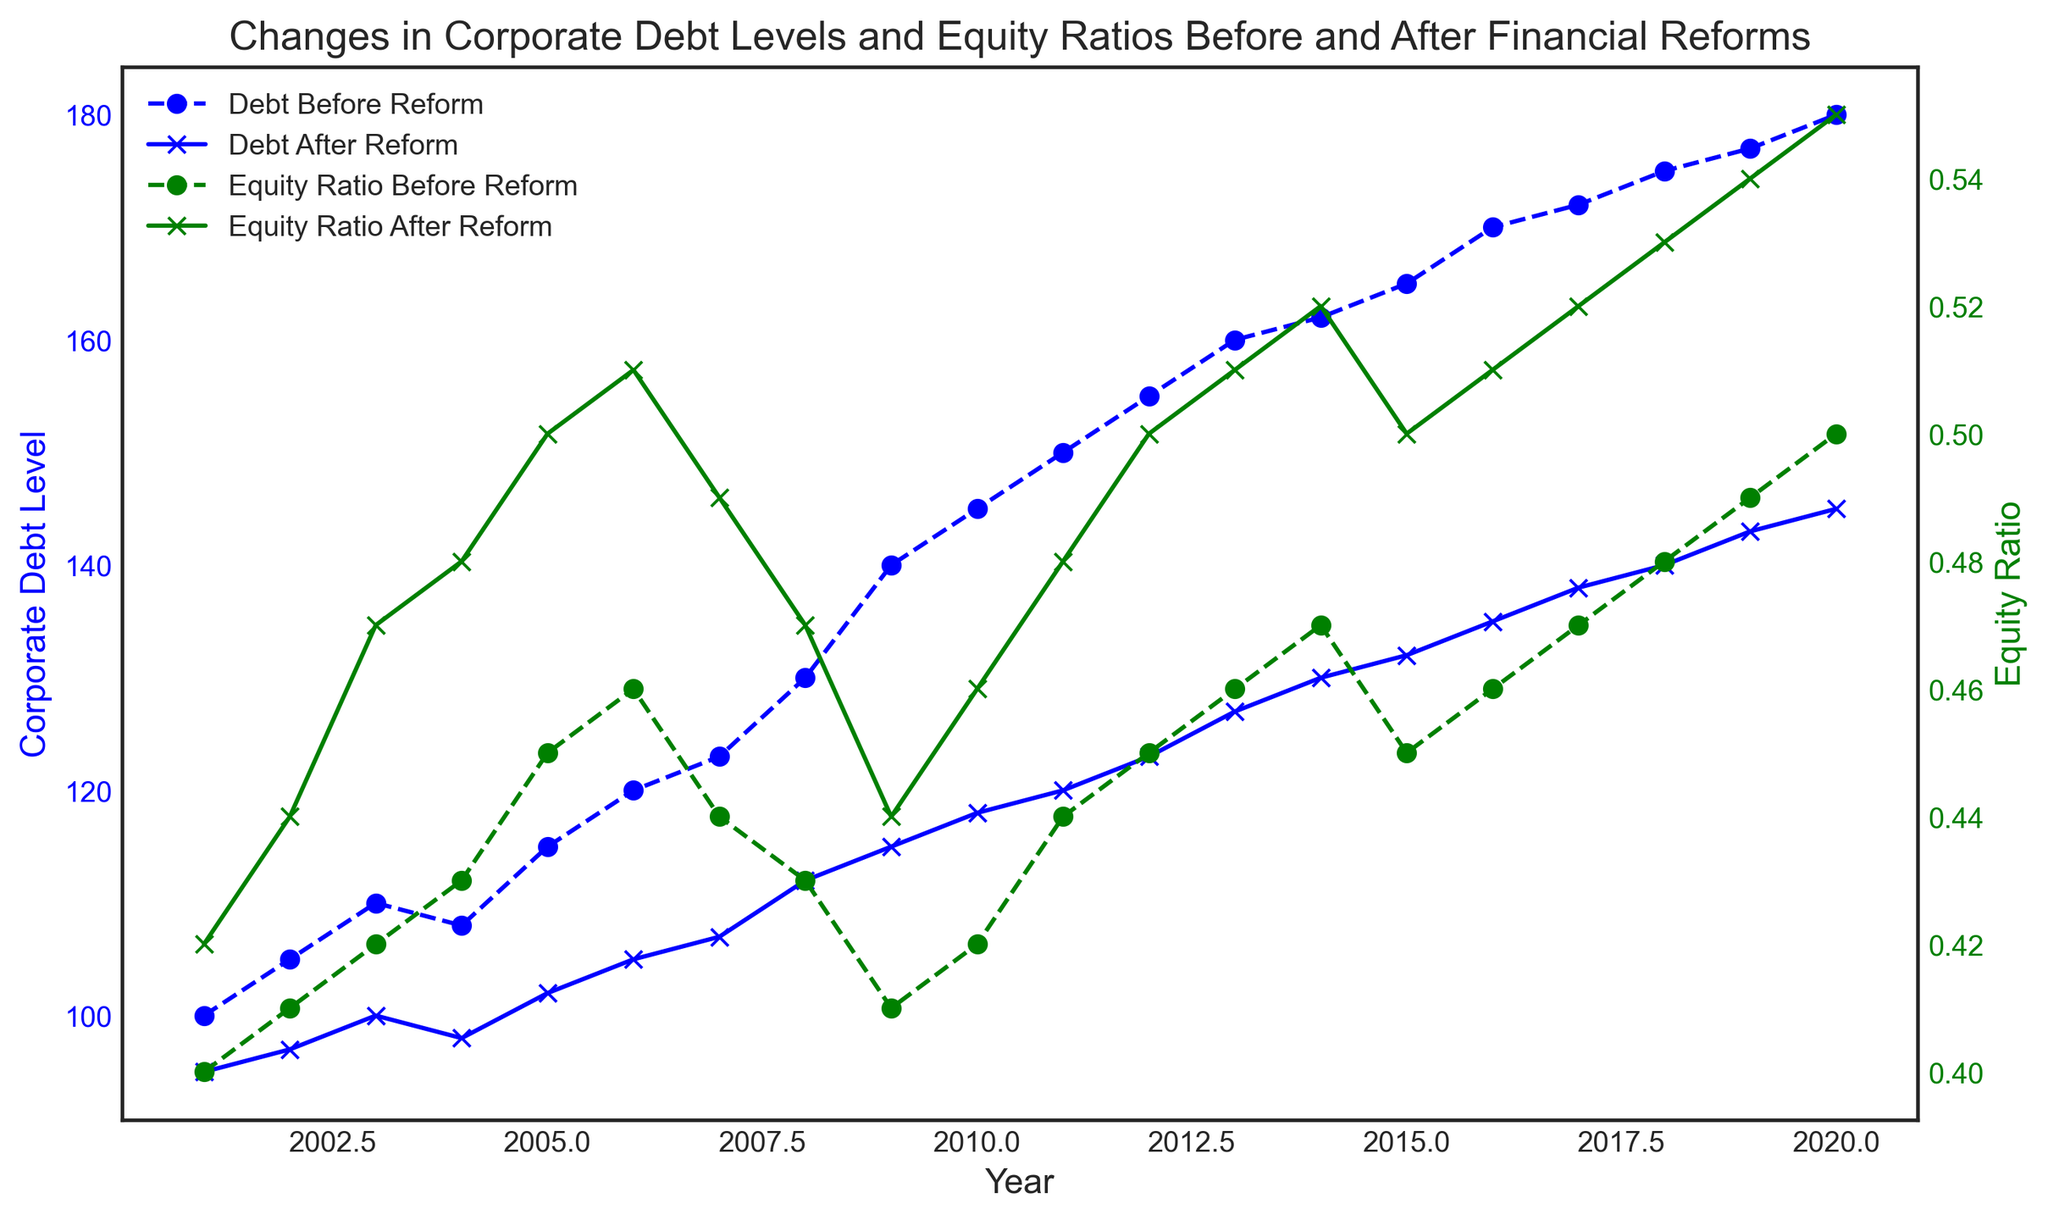What is the overall trend in the Corporate Debt Level before the reform from 2001 to 2020? The Corporate Debt Level before the reform shows a general increasing trend from 100 in 2001 to 180 in 2020, with some fluctuations in between.
Answer: Increasing trend Which year shows the largest difference in corporate debt levels between before and after the reform? The largest difference in corporate debt levels between before and after the reform occurs in 2020, with a difference of 35 (180 before, 145 after).
Answer: 2020 How do the Equity Ratios in 2009 compare before and after the reform? In 2009, the Equity Ratio before the reform is 0.41, and the Equity Ratio after the reform is 0.44. Therefore, the Equity Ratio after the reform is higher.
Answer: Higher after reform How did the Corporate Debt Level after the reform change from 2008 to 2009? The Corporate Debt Level after the reform increased from 112 in 2008 to 115 in 2009, indicating a rise of 3 units.
Answer: Increased by 3 units What are the Equity Ratios in the year 2015 both before and after the reform? In 2015, the Equity Ratio before the reform is 0.45, and after the reform, it is 0.50.
Answer: Before: 0.45, After: 0.50 Which year saw the highest Equity Ratio before the reform, and what was its value? The year 2018 saw the highest Equity Ratio before the reform, with the value being 0.50.
Answer: 2018, 0.50 If we calculate the average Corporate Debt Level before the reform from 2001 to 2010, what would it be? Sum the Corporate Debt Levels for the years 2001 to 2010: 100 + 105 + 110 + 108 + 115 + 120 + 123 + 130 + 140 + 145 = 1196. Divide by 10 for the average: 1196/10 = 119.6.
Answer: 119.6 How does the trend in Equity Ratio after the reform from 2016 to 2020 compare to the trend before the reform over the same period? From 2016 to 2020, the Equity Ratio after the reform steadily increases from 0.51 to 0.55. Before the reform, it also increases but at a slightly slower rate, from 0.46 to 0.50. Both trends are increasing, but the post-reform trend is slightly steeper.
Answer: Both increasing, post-reform trend steeper What visual indicators help you distinguish between pre-reform and post-reform data in the line chart? The pre-reform data is represented with dashed lines and circular markers, while the post-reform data uses solid lines and 'x' markers. Additionally, the color coding (blue for debt levels, green for equity ratios) aids in distinguishing them.
Answer: Line style and markers 